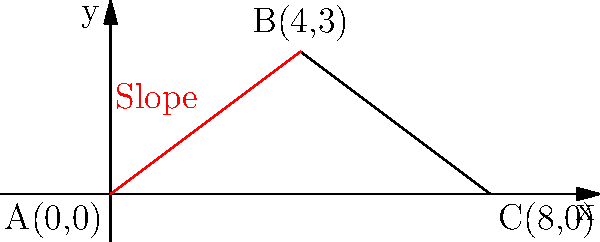In an educational trip to Egypt, you're exploring the Great Pyramid of Giza with your students. Using the simplified model of the pyramid's face shown in the diagram, calculate the slope of the pyramid's face. How does this relate to the ancient Egyptians' understanding of geometry and engineering? To calculate the slope of the pyramid's face, we'll use the linear equation slope formula:

$$ m = \frac{y_2 - y_1}{x_2 - x_1} $$

Where $(x_1, y_1)$ is the starting point and $(x_2, y_2)$ is the ending point.

Step 1: Identify the coordinates
- Point A: $(0, 0)$
- Point B: $(4, 3)$

Step 2: Apply the slope formula
$$ m = \frac{3 - 0}{4 - 0} = \frac{3}{4} = 0.75 $$

Step 3: Interpret the result
The slope of 0.75 means that for every 4 units of horizontal distance, the pyramid rises 3 units vertically.

This precise slope demonstrates the ancient Egyptians' advanced understanding of geometry and engineering. They likely used a similar concept to the modern "rise over run" to maintain consistent angles and ensure structural stability. This knowledge allowed them to create monumental structures that have endured for millennia.

The use of such precise measurements and ratios in ancient architecture reflects a sophisticated grasp of mathematical principles, which can be used to engage students in discussions about the practical applications of geometry in historical contexts.
Answer: $\frac{3}{4}$ or 0.75 